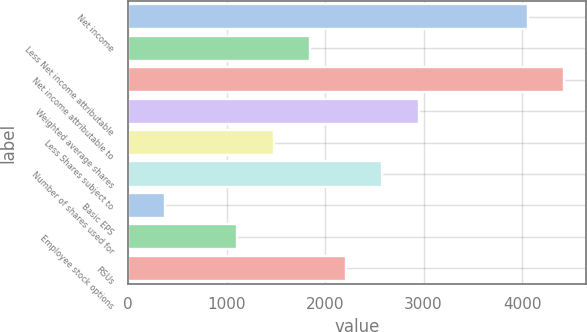Convert chart. <chart><loc_0><loc_0><loc_500><loc_500><bar_chart><fcel>Net income<fcel>Less Net income attributable<fcel>Net income attributable to<fcel>Weighted average shares<fcel>Less Shares subject to<fcel>Number of shares used for<fcel>Basic EPS<fcel>Employee stock options<fcel>RSUs<nl><fcel>4056.66<fcel>1844.64<fcel>4425.33<fcel>2950.65<fcel>1475.97<fcel>2581.98<fcel>369.96<fcel>1107.3<fcel>2213.31<nl></chart> 